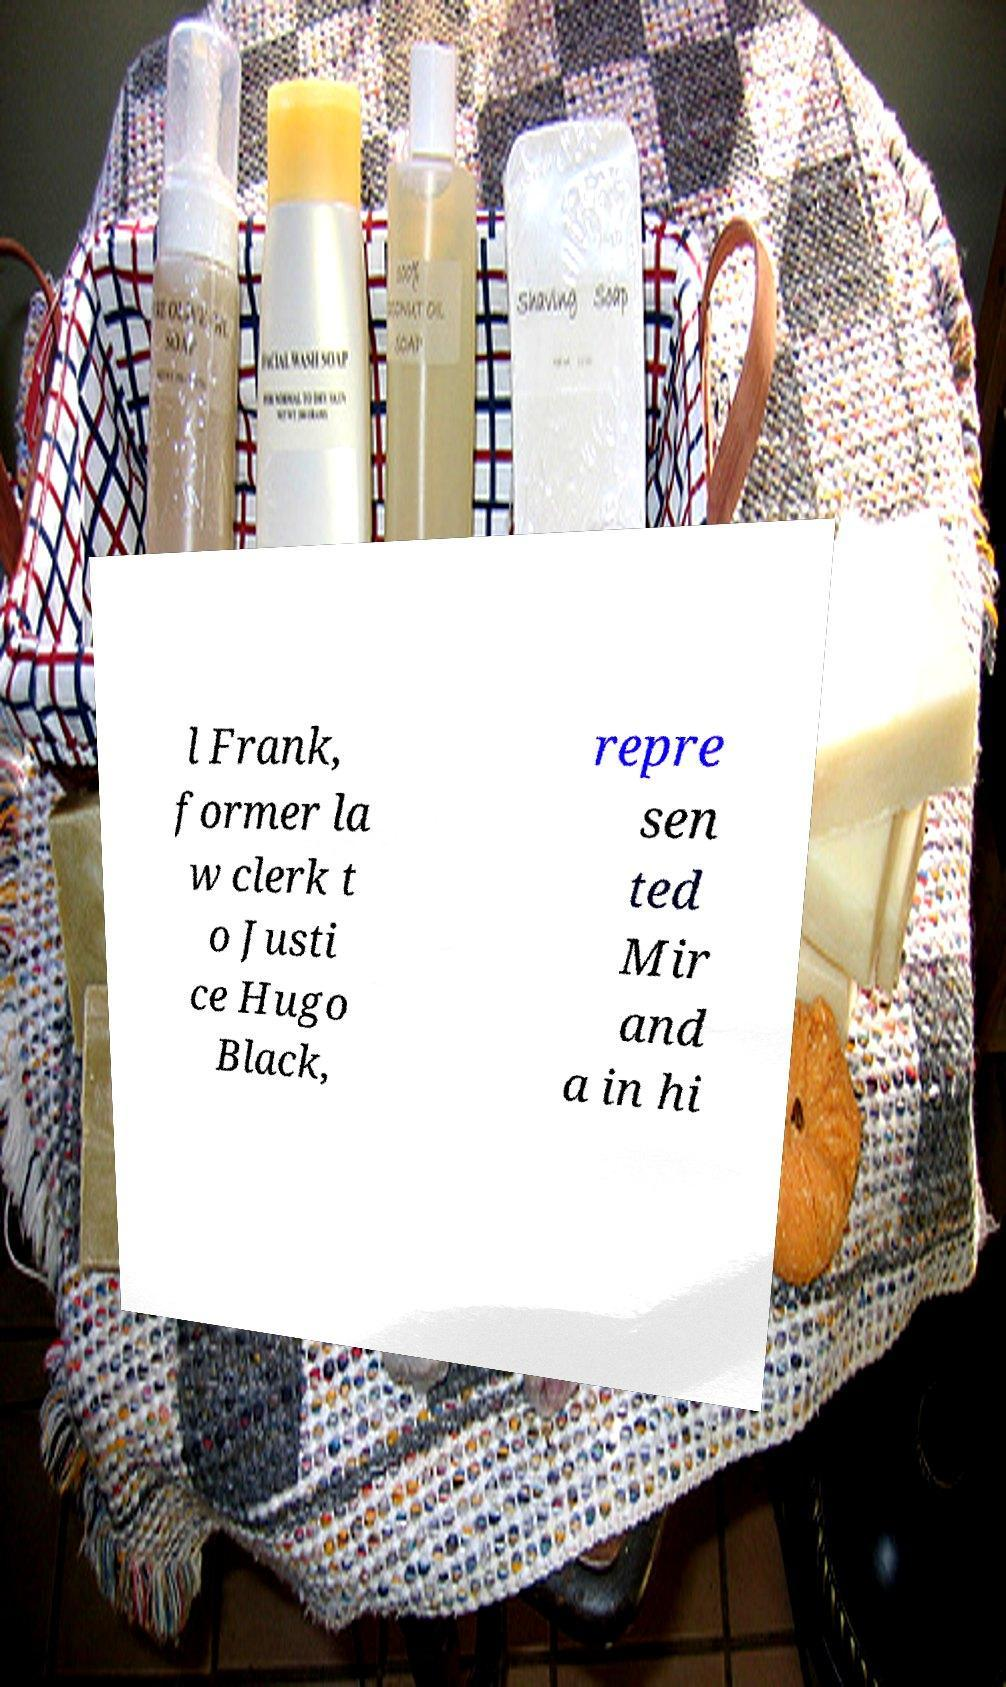What messages or text are displayed in this image? I need them in a readable, typed format. l Frank, former la w clerk t o Justi ce Hugo Black, repre sen ted Mir and a in hi 